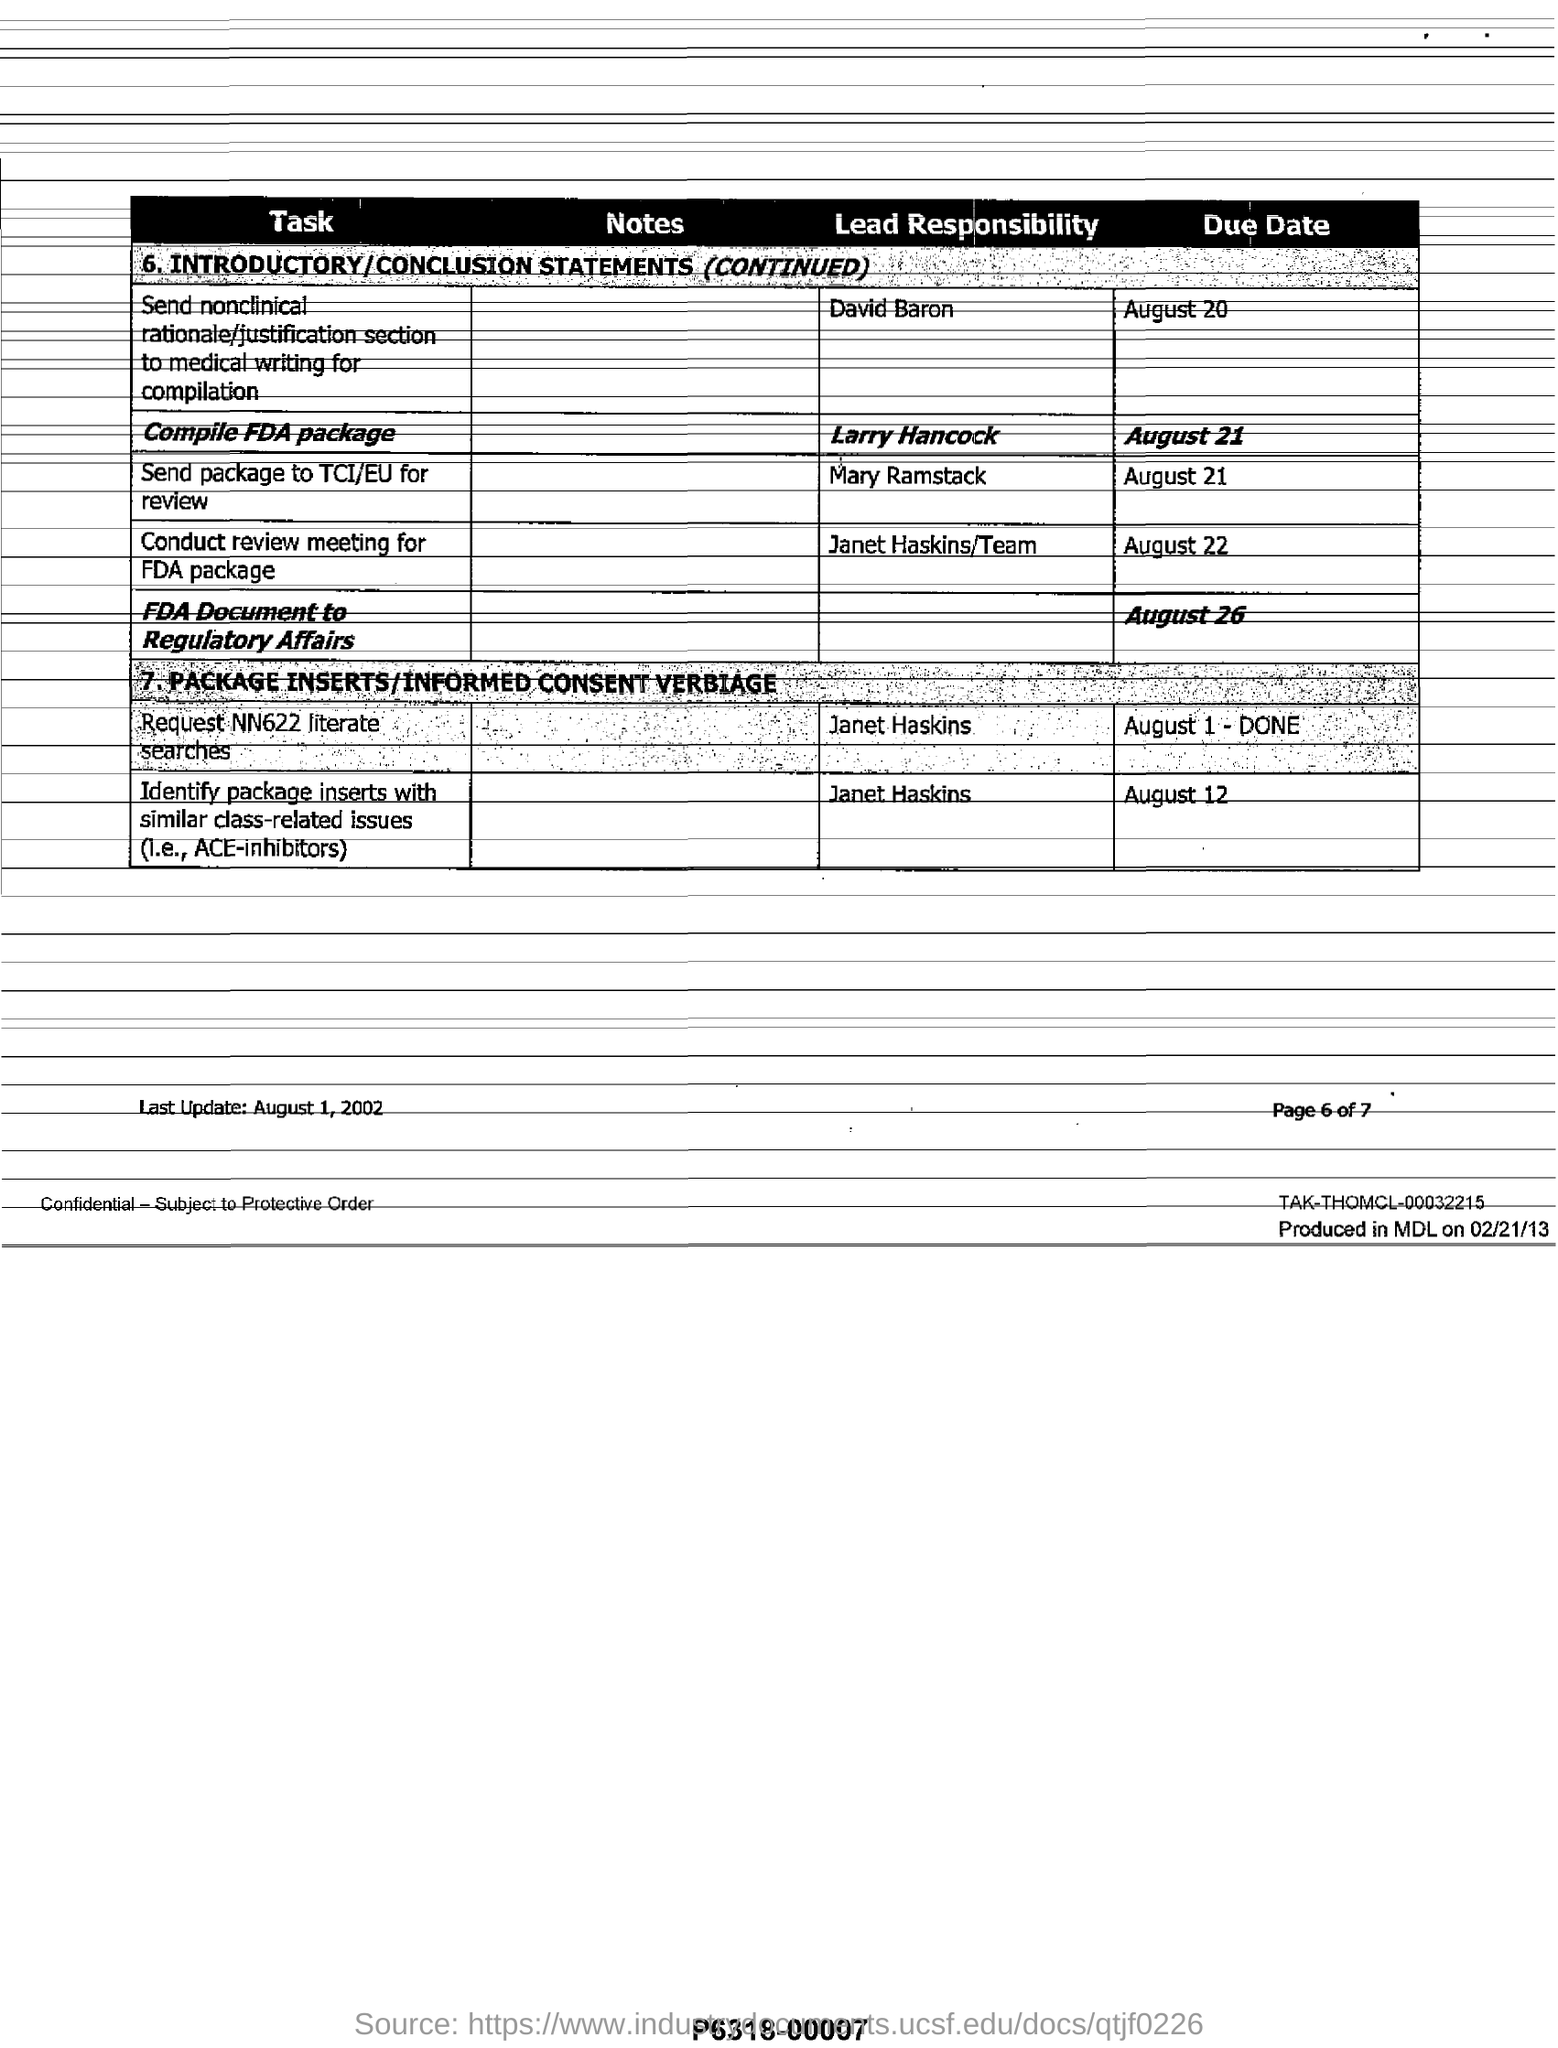Mention a couple of crucial points in this snapshot. It has been assigned to David Baron to send the nonclinical rationale/justification section to medical writing for compilation. The compilation of the FDA package is the responsibility of Larry Hancock. The due date for sending the FDA document to Regulatory Affairs is August 26. The due date to conduct a review meeting for the FDA package is August 22. Mary Ramstack is responsible for sending the package to the TCI/EU for review. 